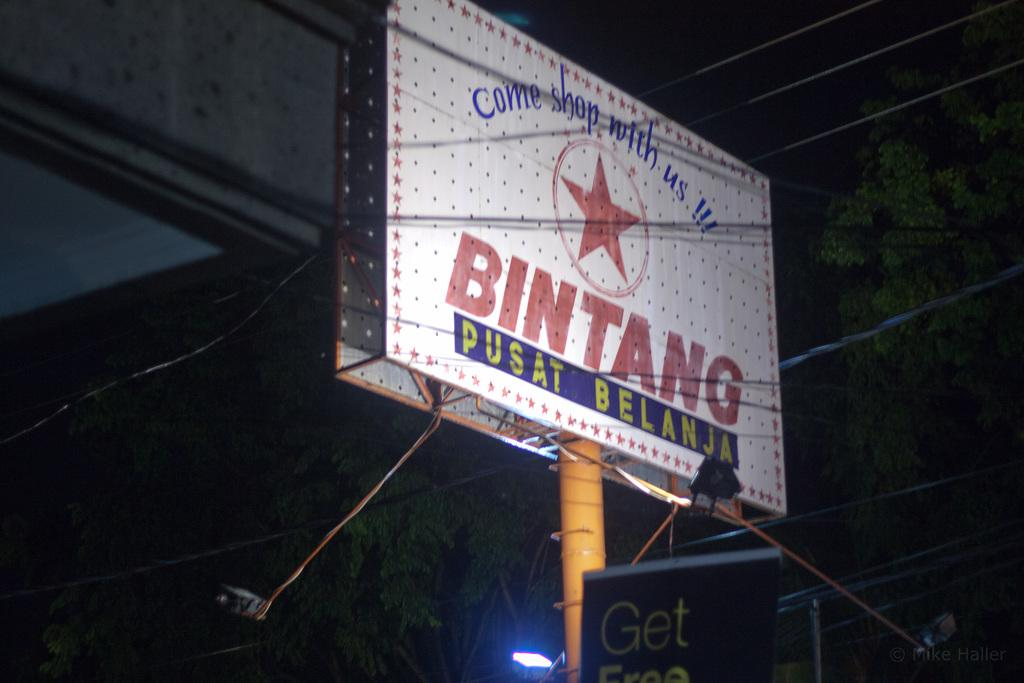<image>
Give a short and clear explanation of the subsequent image. An enthusiastic billboard invites consumers to "come shop" with them. 